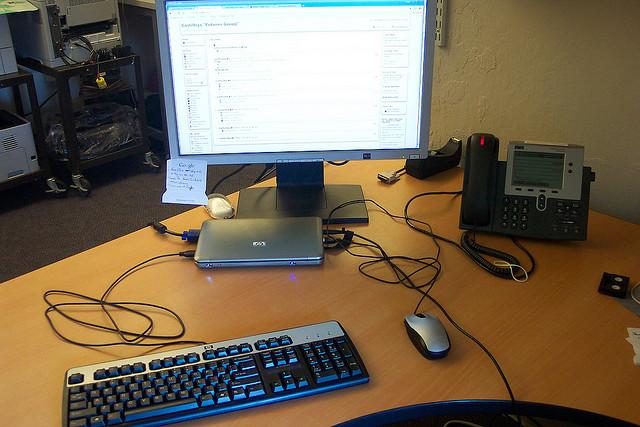Is there a light on the telephone?
Short answer required. Yes. Was this photo taken at an office?
Short answer required. Yes. What color is the telephone handle?
Quick response, please. Black. 